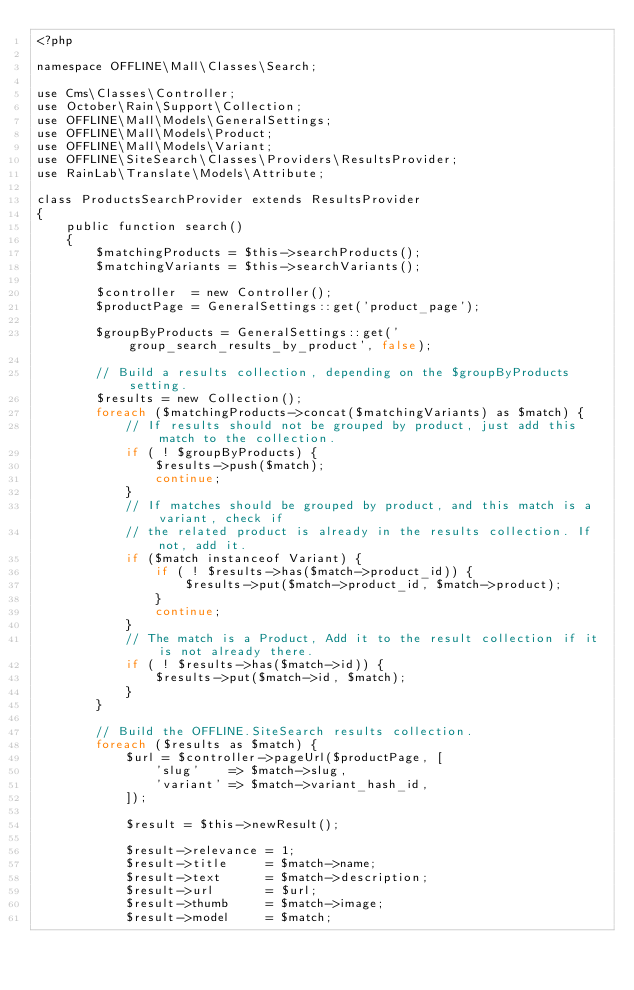Convert code to text. <code><loc_0><loc_0><loc_500><loc_500><_PHP_><?php

namespace OFFLINE\Mall\Classes\Search;

use Cms\Classes\Controller;
use October\Rain\Support\Collection;
use OFFLINE\Mall\Models\GeneralSettings;
use OFFLINE\Mall\Models\Product;
use OFFLINE\Mall\Models\Variant;
use OFFLINE\SiteSearch\Classes\Providers\ResultsProvider;
use RainLab\Translate\Models\Attribute;

class ProductsSearchProvider extends ResultsProvider
{
    public function search()
    {
        $matchingProducts = $this->searchProducts();
        $matchingVariants = $this->searchVariants();

        $controller  = new Controller();
        $productPage = GeneralSettings::get('product_page');

        $groupByProducts = GeneralSettings::get('group_search_results_by_product', false);

        // Build a results collection, depending on the $groupByProducts setting.
        $results = new Collection();
        foreach ($matchingProducts->concat($matchingVariants) as $match) {
            // If results should not be grouped by product, just add this match to the collection.
            if ( ! $groupByProducts) {
                $results->push($match);
                continue;
            }
            // If matches should be grouped by product, and this match is a variant, check if
            // the related product is already in the results collection. If not, add it.
            if ($match instanceof Variant) {
                if ( ! $results->has($match->product_id)) {
                    $results->put($match->product_id, $match->product);
                }
                continue;
            }
            // The match is a Product, Add it to the result collection if it is not already there.
            if ( ! $results->has($match->id)) {
                $results->put($match->id, $match);
            }
        }

        // Build the OFFLINE.SiteSearch results collection.
        foreach ($results as $match) {
            $url = $controller->pageUrl($productPage, [
                'slug'    => $match->slug,
                'variant' => $match->variant_hash_id,
            ]);

            $result = $this->newResult();

            $result->relevance = 1;
            $result->title     = $match->name;
            $result->text      = $match->description;
            $result->url       = $url;
            $result->thumb     = $match->image;
            $result->model     = $match;</code> 